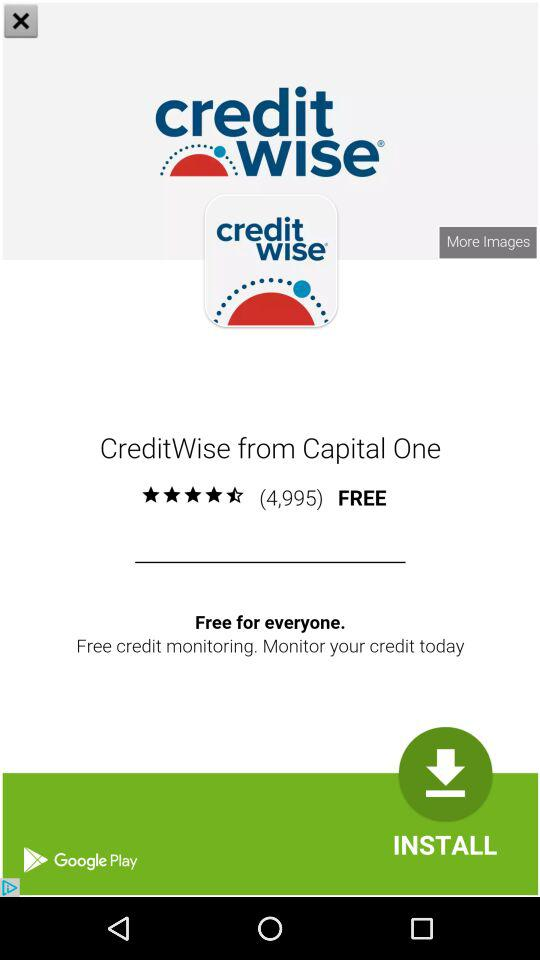How many stars are given to "CreditWise from Capital One"? There are 4.5 stars given to "CreditWise from Capital One". 